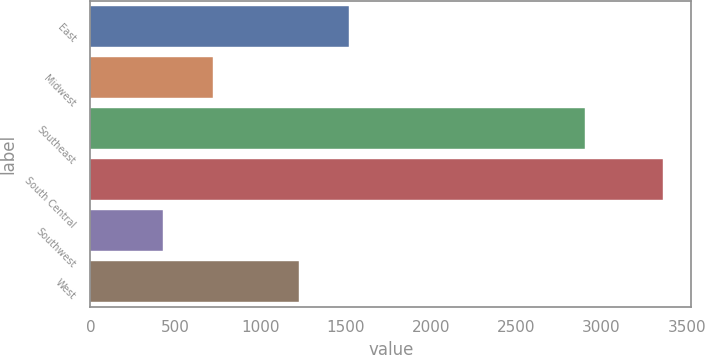<chart> <loc_0><loc_0><loc_500><loc_500><bar_chart><fcel>East<fcel>Midwest<fcel>Southeast<fcel>South Central<fcel>Southwest<fcel>West<nl><fcel>1519.3<fcel>718.3<fcel>2901<fcel>3358<fcel>425<fcel>1226<nl></chart> 